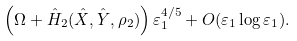<formula> <loc_0><loc_0><loc_500><loc_500>\left ( \Omega + \hat { H } _ { 2 } ( \hat { X } , \hat { Y } , \rho _ { 2 } ) \right ) \varepsilon _ { 1 } ^ { 4 / 5 } + O ( \varepsilon _ { 1 } \log \varepsilon _ { 1 } ) .</formula> 